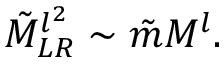<formula> <loc_0><loc_0><loc_500><loc_500>\tilde { M } _ { L R } ^ { l ^ { 2 } } \sim \tilde { m } M ^ { l } .</formula> 